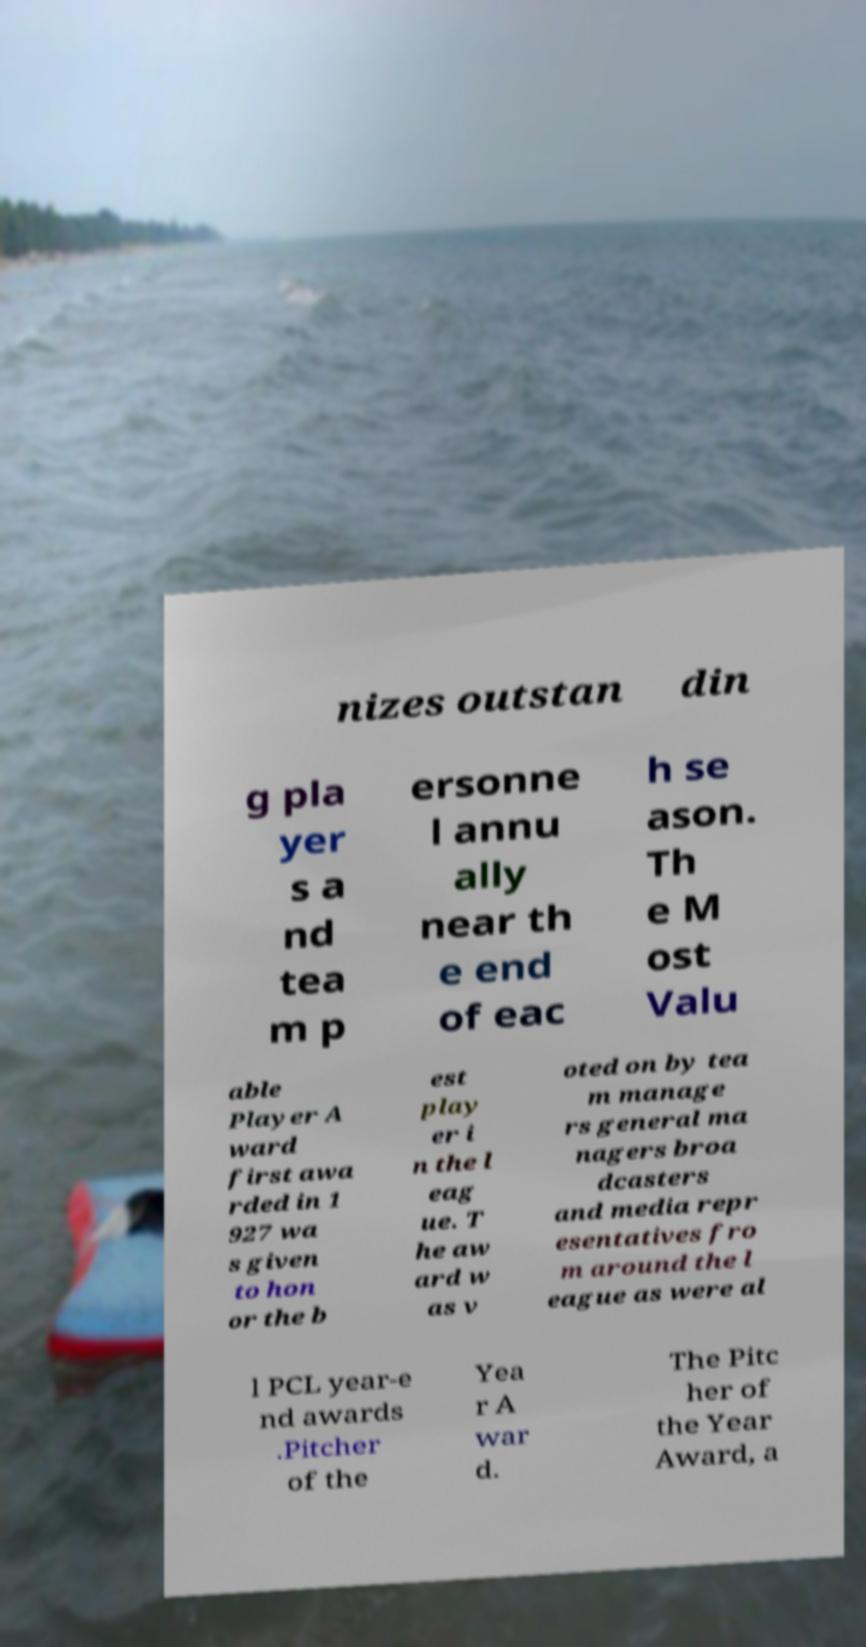Could you extract and type out the text from this image? nizes outstan din g pla yer s a nd tea m p ersonne l annu ally near th e end of eac h se ason. Th e M ost Valu able Player A ward first awa rded in 1 927 wa s given to hon or the b est play er i n the l eag ue. T he aw ard w as v oted on by tea m manage rs general ma nagers broa dcasters and media repr esentatives fro m around the l eague as were al l PCL year-e nd awards .Pitcher of the Yea r A war d. The Pitc her of the Year Award, a 